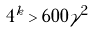Convert formula to latex. <formula><loc_0><loc_0><loc_500><loc_500>4 ^ { k } > 6 0 0 \gamma ^ { 2 }</formula> 